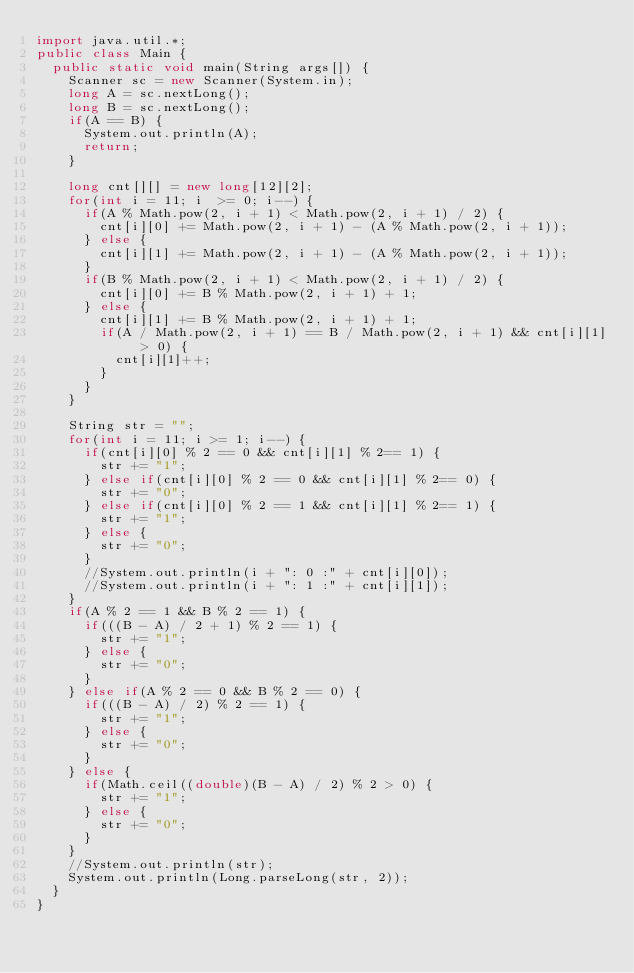Convert code to text. <code><loc_0><loc_0><loc_500><loc_500><_Java_>import java.util.*;
public class Main {
	public static void main(String args[]) {
		Scanner sc = new Scanner(System.in);
		long A = sc.nextLong();
		long B = sc.nextLong();
		if(A == B) {
			System.out.println(A);
			return;
		}
		
		long cnt[][] = new long[12][2];
		for(int i = 11; i  >= 0; i--) {
			if(A % Math.pow(2, i + 1) < Math.pow(2, i + 1) / 2) {
				cnt[i][0] += Math.pow(2, i + 1) - (A % Math.pow(2, i + 1));
			} else {
				cnt[i][1] += Math.pow(2, i + 1) - (A % Math.pow(2, i + 1));
			}
			if(B % Math.pow(2, i + 1) < Math.pow(2, i + 1) / 2) {
				cnt[i][0] += B % Math.pow(2, i + 1) + 1;
			} else {
				cnt[i][1] += B % Math.pow(2, i + 1) + 1;
				if(A / Math.pow(2, i + 1) == B / Math.pow(2, i + 1) && cnt[i][1] > 0) {
					cnt[i][1]++;
				}
			}
		}
		
		String str = "";
		for(int i = 11; i >= 1; i--) {
			if(cnt[i][0] % 2 == 0 && cnt[i][1] % 2== 1) {
				str += "1";
			} else if(cnt[i][0] % 2 == 0 && cnt[i][1] % 2== 0) {
				str += "0";
			} else if(cnt[i][0] % 2 == 1 && cnt[i][1] % 2== 1) {
				str += "1";
			} else {
				str += "0";
			}
			//System.out.println(i + ": 0 :" + cnt[i][0]);
			//System.out.println(i + ": 1 :" + cnt[i][1]);
		}
		if(A % 2 == 1 && B % 2 == 1) {
			if(((B - A) / 2 + 1) % 2 == 1) {
				str += "1";
			} else {
				str += "0";
			}
		} else if(A % 2 == 0 && B % 2 == 0) {
			if(((B - A) / 2) % 2 == 1) {
				str += "1";
			} else {
				str += "0";
			}
		} else {
			if(Math.ceil((double)(B - A) / 2) % 2 > 0) {
				str += "1";
			} else {
				str += "0";
			}
		}
		//System.out.println(str);
		System.out.println(Long.parseLong(str, 2));
	}
}
</code> 